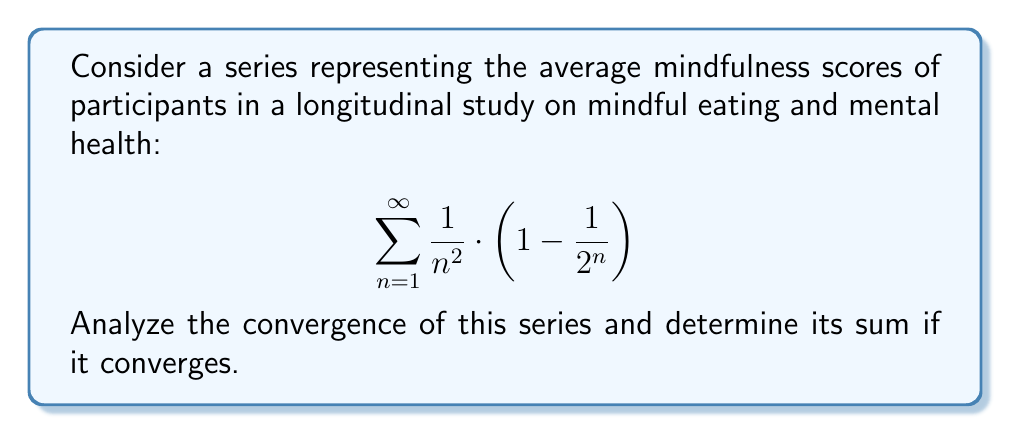Teach me how to tackle this problem. To analyze the convergence of this series, we'll follow these steps:

1) First, let's examine the general term of the series:

   $$a_n = \frac{1}{n^2} \cdot \left(1 - \frac{1}{2^n}\right)$$

2) We can split this into two series:

   $$\sum_{n=1}^{\infty} \frac{1}{n^2} - \sum_{n=1}^{\infty} \frac{1}{n^2 \cdot 2^n}$$

3) The first series $\sum_{n=1}^{\infty} \frac{1}{n^2}$ is the well-known Basel problem series, which converges to $\frac{\pi^2}{6}$.

4) For the second series $\sum_{n=1}^{\infty} \frac{1}{n^2 \cdot 2^n}$, we can use the ratio test:

   $$\lim_{n \to \infty} \left|\frac{a_{n+1}}{a_n}\right| = \lim_{n \to \infty} \frac{n^2}{(n+1)^2} \cdot \frac{1}{2} = \frac{1}{2} < 1$$

   Since the limit is less than 1, this series also converges.

5) By the linearity of convergence, if both series converge, their difference also converges.

6) To find the sum of the second series, we can use the polylogarithm function:

   $$\sum_{n=1}^{\infty} \frac{1}{n^2 \cdot 2^n} = \text{Li}_2\left(\frac{1}{2}\right)$$

   Where $\text{Li}_2(x)$ is the dilogarithm function.

7) The value of $\text{Li}_2\left(\frac{1}{2}\right)$ is known to be $\frac{\pi^2}{12} - \frac{(\ln 2)^2}{2}$.

8) Therefore, the sum of our original series is:

   $$\frac{\pi^2}{6} - \left(\frac{\pi^2}{12} - \frac{(\ln 2)^2}{2}\right) = \frac{\pi^2}{12} + \frac{(\ln 2)^2}{2}$$

Thus, the series converges, and we have found its sum.
Answer: The series converges, and its sum is $\frac{\pi^2}{12} + \frac{(\ln 2)^2}{2}$. 